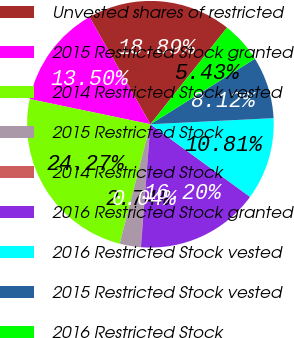<chart> <loc_0><loc_0><loc_500><loc_500><pie_chart><fcel>Unvested shares of restricted<fcel>2015 Restricted Stock granted<fcel>2014 Restricted Stock vested<fcel>2015 Restricted Stock<fcel>2014 Restricted Stock<fcel>2016 Restricted Stock granted<fcel>2016 Restricted Stock vested<fcel>2015 Restricted Stock vested<fcel>2016 Restricted Stock<nl><fcel>18.89%<fcel>13.5%<fcel>24.27%<fcel>2.74%<fcel>0.04%<fcel>16.2%<fcel>10.81%<fcel>8.12%<fcel>5.43%<nl></chart> 